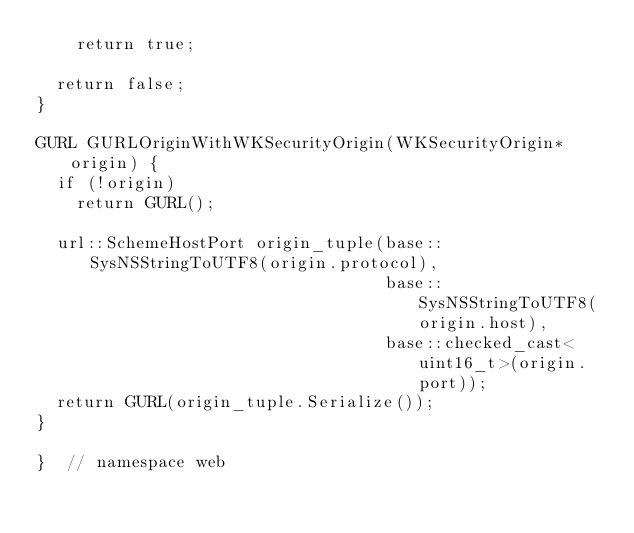<code> <loc_0><loc_0><loc_500><loc_500><_ObjectiveC_>    return true;

  return false;
}

GURL GURLOriginWithWKSecurityOrigin(WKSecurityOrigin* origin) {
  if (!origin)
    return GURL();

  url::SchemeHostPort origin_tuple(base::SysNSStringToUTF8(origin.protocol),
                                   base::SysNSStringToUTF8(origin.host),
                                   base::checked_cast<uint16_t>(origin.port));
  return GURL(origin_tuple.Serialize());
}

}  // namespace web
</code> 